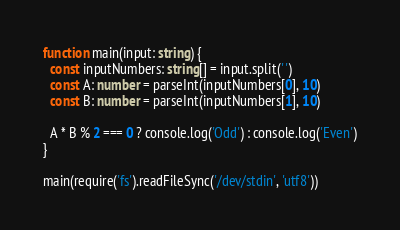Convert code to text. <code><loc_0><loc_0><loc_500><loc_500><_TypeScript_>function main(input: string) {
  const inputNumbers: string[] = input.split(' ')
  const A: number = parseInt(inputNumbers[0], 10)
  const B: number = parseInt(inputNumbers[1], 10)

  A * B % 2 === 0 ? console.log('Odd') : console.log('Even')
}

main(require('fs').readFileSync('/dev/stdin', 'utf8'))</code> 